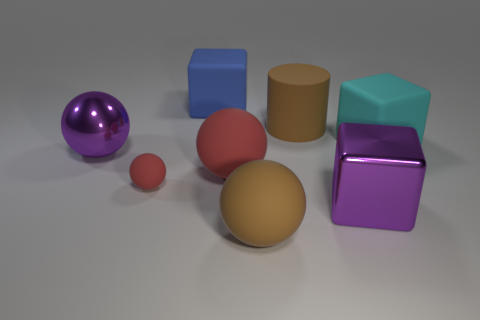There is a red sphere that is the same size as the blue thing; what is its material?
Your answer should be very brief. Rubber. There is a metal object in front of the purple ball; what size is it?
Your answer should be compact. Large. Does the shiny cube in front of the brown rubber cylinder have the same size as the purple thing left of the blue rubber cube?
Provide a succinct answer. Yes. What number of other large objects have the same material as the big blue object?
Ensure brevity in your answer.  4. What is the color of the metallic sphere?
Offer a very short reply. Purple. There is a brown cylinder; are there any brown matte balls behind it?
Offer a very short reply. No. Is the large shiny ball the same color as the metallic block?
Keep it short and to the point. Yes. How many big matte things have the same color as the small matte sphere?
Provide a short and direct response. 1. What is the size of the brown matte thing that is behind the large matte block that is right of the blue matte thing?
Make the answer very short. Large. The big blue object is what shape?
Make the answer very short. Cube. 